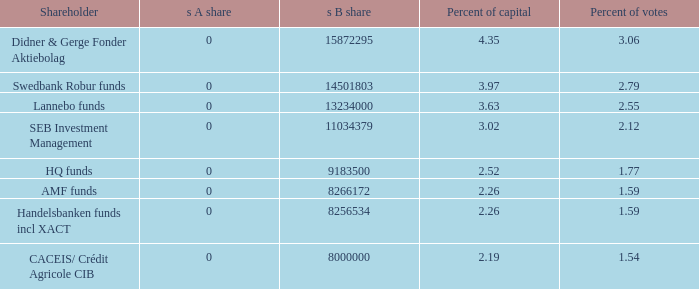What is the s b stake for the investor holding 13234000.0. 